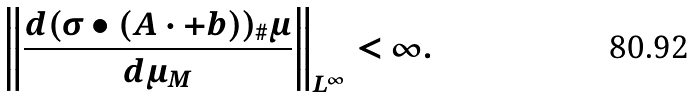<formula> <loc_0><loc_0><loc_500><loc_500>\left \| \frac { d ( \sigma \bullet ( A \cdot + b ) ) _ { \# } \mu } { d \mu _ { M } } \right \| _ { L ^ { \infty } } < \infty .</formula> 